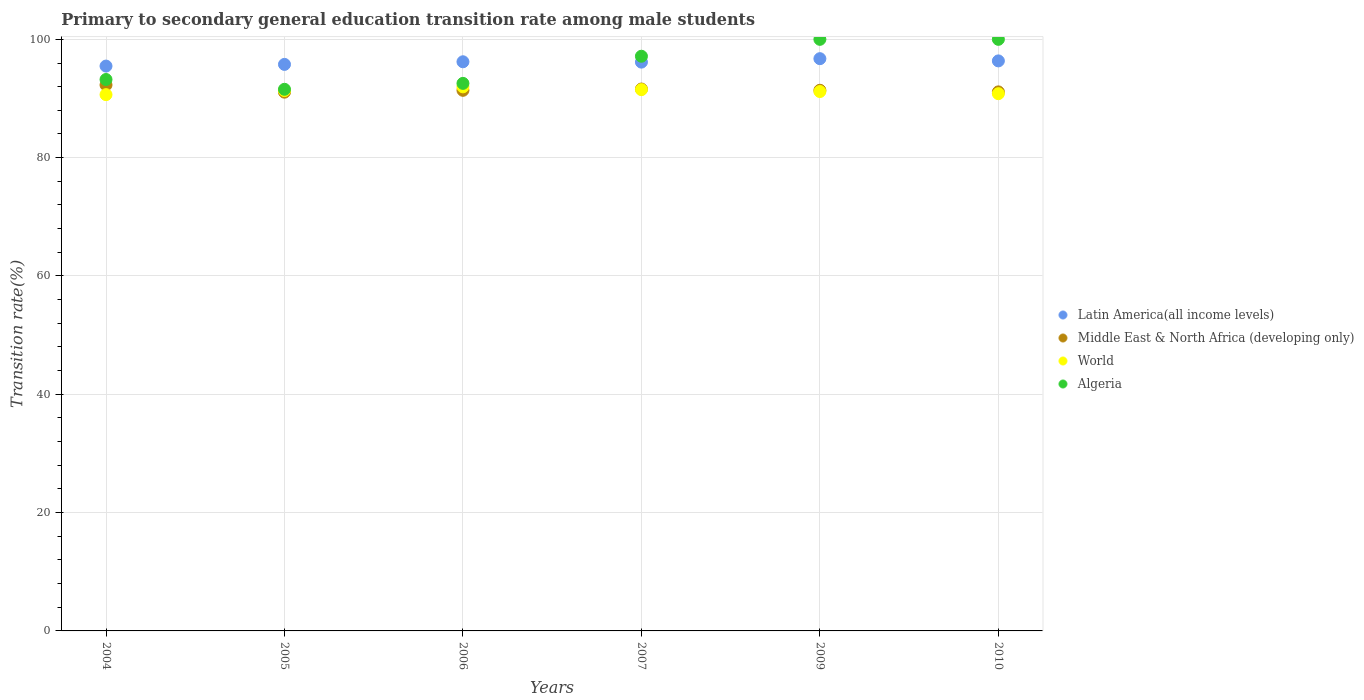How many different coloured dotlines are there?
Your answer should be compact. 4. Is the number of dotlines equal to the number of legend labels?
Your response must be concise. Yes. What is the transition rate in World in 2007?
Keep it short and to the point. 91.5. Across all years, what is the maximum transition rate in Middle East & North Africa (developing only)?
Offer a terse response. 92.29. Across all years, what is the minimum transition rate in World?
Your answer should be compact. 90.65. In which year was the transition rate in Algeria maximum?
Offer a terse response. 2009. In which year was the transition rate in Middle East & North Africa (developing only) minimum?
Make the answer very short. 2005. What is the total transition rate in Middle East & North Africa (developing only) in the graph?
Keep it short and to the point. 548.86. What is the difference between the transition rate in Latin America(all income levels) in 2005 and that in 2007?
Ensure brevity in your answer.  -0.38. What is the difference between the transition rate in Latin America(all income levels) in 2004 and the transition rate in World in 2007?
Make the answer very short. 3.98. What is the average transition rate in Latin America(all income levels) per year?
Your answer should be compact. 96.11. In the year 2009, what is the difference between the transition rate in Middle East & North Africa (developing only) and transition rate in World?
Offer a very short reply. 0.22. What is the ratio of the transition rate in Middle East & North Africa (developing only) in 2007 to that in 2010?
Your answer should be compact. 1.01. Is the transition rate in World in 2005 less than that in 2007?
Offer a terse response. Yes. What is the difference between the highest and the second highest transition rate in World?
Your answer should be very brief. 0.47. What is the difference between the highest and the lowest transition rate in World?
Your answer should be very brief. 1.32. In how many years, is the transition rate in Middle East & North Africa (developing only) greater than the average transition rate in Middle East & North Africa (developing only) taken over all years?
Ensure brevity in your answer.  2. Is the sum of the transition rate in World in 2009 and 2010 greater than the maximum transition rate in Middle East & North Africa (developing only) across all years?
Provide a succinct answer. Yes. Does the transition rate in Middle East & North Africa (developing only) monotonically increase over the years?
Provide a succinct answer. No. Is the transition rate in Latin America(all income levels) strictly greater than the transition rate in Middle East & North Africa (developing only) over the years?
Offer a terse response. Yes. How many dotlines are there?
Your answer should be very brief. 4. How many years are there in the graph?
Provide a short and direct response. 6. What is the difference between two consecutive major ticks on the Y-axis?
Your response must be concise. 20. Are the values on the major ticks of Y-axis written in scientific E-notation?
Keep it short and to the point. No. Where does the legend appear in the graph?
Provide a short and direct response. Center right. How many legend labels are there?
Ensure brevity in your answer.  4. How are the legend labels stacked?
Your answer should be compact. Vertical. What is the title of the graph?
Your response must be concise. Primary to secondary general education transition rate among male students. What is the label or title of the X-axis?
Offer a terse response. Years. What is the label or title of the Y-axis?
Make the answer very short. Transition rate(%). What is the Transition rate(%) of Latin America(all income levels) in 2004?
Your answer should be compact. 95.48. What is the Transition rate(%) of Middle East & North Africa (developing only) in 2004?
Your answer should be compact. 92.29. What is the Transition rate(%) in World in 2004?
Your answer should be very brief. 90.65. What is the Transition rate(%) in Algeria in 2004?
Provide a short and direct response. 93.21. What is the Transition rate(%) of Latin America(all income levels) in 2005?
Your answer should be very brief. 95.76. What is the Transition rate(%) in Middle East & North Africa (developing only) in 2005?
Keep it short and to the point. 91.07. What is the Transition rate(%) in World in 2005?
Provide a short and direct response. 91.34. What is the Transition rate(%) of Algeria in 2005?
Provide a short and direct response. 91.56. What is the Transition rate(%) in Latin America(all income levels) in 2006?
Provide a succinct answer. 96.21. What is the Transition rate(%) in Middle East & North Africa (developing only) in 2006?
Make the answer very short. 91.38. What is the Transition rate(%) in World in 2006?
Offer a very short reply. 91.97. What is the Transition rate(%) in Algeria in 2006?
Offer a terse response. 92.56. What is the Transition rate(%) of Latin America(all income levels) in 2007?
Offer a terse response. 96.15. What is the Transition rate(%) in Middle East & North Africa (developing only) in 2007?
Offer a very short reply. 91.6. What is the Transition rate(%) of World in 2007?
Provide a short and direct response. 91.5. What is the Transition rate(%) in Algeria in 2007?
Give a very brief answer. 97.14. What is the Transition rate(%) in Latin America(all income levels) in 2009?
Keep it short and to the point. 96.73. What is the Transition rate(%) of Middle East & North Africa (developing only) in 2009?
Provide a short and direct response. 91.39. What is the Transition rate(%) of World in 2009?
Offer a very short reply. 91.18. What is the Transition rate(%) in Latin America(all income levels) in 2010?
Provide a succinct answer. 96.36. What is the Transition rate(%) of Middle East & North Africa (developing only) in 2010?
Provide a short and direct response. 91.12. What is the Transition rate(%) in World in 2010?
Offer a very short reply. 90.81. What is the Transition rate(%) of Algeria in 2010?
Offer a very short reply. 100. Across all years, what is the maximum Transition rate(%) in Latin America(all income levels)?
Provide a succinct answer. 96.73. Across all years, what is the maximum Transition rate(%) of Middle East & North Africa (developing only)?
Provide a short and direct response. 92.29. Across all years, what is the maximum Transition rate(%) in World?
Your answer should be very brief. 91.97. Across all years, what is the minimum Transition rate(%) in Latin America(all income levels)?
Offer a very short reply. 95.48. Across all years, what is the minimum Transition rate(%) in Middle East & North Africa (developing only)?
Offer a terse response. 91.07. Across all years, what is the minimum Transition rate(%) of World?
Your answer should be compact. 90.65. Across all years, what is the minimum Transition rate(%) in Algeria?
Make the answer very short. 91.56. What is the total Transition rate(%) in Latin America(all income levels) in the graph?
Ensure brevity in your answer.  576.69. What is the total Transition rate(%) of Middle East & North Africa (developing only) in the graph?
Your answer should be very brief. 548.86. What is the total Transition rate(%) in World in the graph?
Offer a very short reply. 547.45. What is the total Transition rate(%) of Algeria in the graph?
Give a very brief answer. 574.47. What is the difference between the Transition rate(%) of Latin America(all income levels) in 2004 and that in 2005?
Provide a short and direct response. -0.28. What is the difference between the Transition rate(%) in Middle East & North Africa (developing only) in 2004 and that in 2005?
Provide a succinct answer. 1.22. What is the difference between the Transition rate(%) in World in 2004 and that in 2005?
Offer a very short reply. -0.69. What is the difference between the Transition rate(%) in Algeria in 2004 and that in 2005?
Ensure brevity in your answer.  1.66. What is the difference between the Transition rate(%) of Latin America(all income levels) in 2004 and that in 2006?
Give a very brief answer. -0.73. What is the difference between the Transition rate(%) in Middle East & North Africa (developing only) in 2004 and that in 2006?
Give a very brief answer. 0.91. What is the difference between the Transition rate(%) of World in 2004 and that in 2006?
Your response must be concise. -1.31. What is the difference between the Transition rate(%) of Algeria in 2004 and that in 2006?
Your answer should be compact. 0.65. What is the difference between the Transition rate(%) in Latin America(all income levels) in 2004 and that in 2007?
Keep it short and to the point. -0.67. What is the difference between the Transition rate(%) in Middle East & North Africa (developing only) in 2004 and that in 2007?
Your answer should be compact. 0.68. What is the difference between the Transition rate(%) in World in 2004 and that in 2007?
Keep it short and to the point. -0.85. What is the difference between the Transition rate(%) in Algeria in 2004 and that in 2007?
Ensure brevity in your answer.  -3.93. What is the difference between the Transition rate(%) in Latin America(all income levels) in 2004 and that in 2009?
Make the answer very short. -1.25. What is the difference between the Transition rate(%) of Middle East & North Africa (developing only) in 2004 and that in 2009?
Make the answer very short. 0.89. What is the difference between the Transition rate(%) in World in 2004 and that in 2009?
Ensure brevity in your answer.  -0.53. What is the difference between the Transition rate(%) in Algeria in 2004 and that in 2009?
Keep it short and to the point. -6.79. What is the difference between the Transition rate(%) in Latin America(all income levels) in 2004 and that in 2010?
Your response must be concise. -0.87. What is the difference between the Transition rate(%) of Middle East & North Africa (developing only) in 2004 and that in 2010?
Keep it short and to the point. 1.17. What is the difference between the Transition rate(%) in World in 2004 and that in 2010?
Your answer should be very brief. -0.16. What is the difference between the Transition rate(%) of Algeria in 2004 and that in 2010?
Provide a short and direct response. -6.79. What is the difference between the Transition rate(%) of Latin America(all income levels) in 2005 and that in 2006?
Offer a terse response. -0.44. What is the difference between the Transition rate(%) of Middle East & North Africa (developing only) in 2005 and that in 2006?
Make the answer very short. -0.31. What is the difference between the Transition rate(%) of World in 2005 and that in 2006?
Offer a very short reply. -0.63. What is the difference between the Transition rate(%) of Algeria in 2005 and that in 2006?
Ensure brevity in your answer.  -1. What is the difference between the Transition rate(%) of Latin America(all income levels) in 2005 and that in 2007?
Keep it short and to the point. -0.38. What is the difference between the Transition rate(%) in Middle East & North Africa (developing only) in 2005 and that in 2007?
Provide a short and direct response. -0.53. What is the difference between the Transition rate(%) in World in 2005 and that in 2007?
Your answer should be compact. -0.16. What is the difference between the Transition rate(%) in Algeria in 2005 and that in 2007?
Your answer should be compact. -5.59. What is the difference between the Transition rate(%) in Latin America(all income levels) in 2005 and that in 2009?
Give a very brief answer. -0.97. What is the difference between the Transition rate(%) of Middle East & North Africa (developing only) in 2005 and that in 2009?
Your answer should be compact. -0.32. What is the difference between the Transition rate(%) of World in 2005 and that in 2009?
Your answer should be very brief. 0.16. What is the difference between the Transition rate(%) of Algeria in 2005 and that in 2009?
Your response must be concise. -8.44. What is the difference between the Transition rate(%) of Latin America(all income levels) in 2005 and that in 2010?
Keep it short and to the point. -0.59. What is the difference between the Transition rate(%) in Middle East & North Africa (developing only) in 2005 and that in 2010?
Your response must be concise. -0.05. What is the difference between the Transition rate(%) in World in 2005 and that in 2010?
Offer a terse response. 0.53. What is the difference between the Transition rate(%) of Algeria in 2005 and that in 2010?
Give a very brief answer. -8.44. What is the difference between the Transition rate(%) of Latin America(all income levels) in 2006 and that in 2007?
Provide a short and direct response. 0.06. What is the difference between the Transition rate(%) of Middle East & North Africa (developing only) in 2006 and that in 2007?
Offer a very short reply. -0.22. What is the difference between the Transition rate(%) of World in 2006 and that in 2007?
Offer a terse response. 0.47. What is the difference between the Transition rate(%) in Algeria in 2006 and that in 2007?
Keep it short and to the point. -4.59. What is the difference between the Transition rate(%) of Latin America(all income levels) in 2006 and that in 2009?
Your answer should be compact. -0.52. What is the difference between the Transition rate(%) of Middle East & North Africa (developing only) in 2006 and that in 2009?
Provide a succinct answer. -0.01. What is the difference between the Transition rate(%) in World in 2006 and that in 2009?
Provide a short and direct response. 0.79. What is the difference between the Transition rate(%) in Algeria in 2006 and that in 2009?
Your answer should be very brief. -7.44. What is the difference between the Transition rate(%) in Latin America(all income levels) in 2006 and that in 2010?
Make the answer very short. -0.15. What is the difference between the Transition rate(%) of Middle East & North Africa (developing only) in 2006 and that in 2010?
Offer a terse response. 0.26. What is the difference between the Transition rate(%) of World in 2006 and that in 2010?
Your answer should be compact. 1.15. What is the difference between the Transition rate(%) in Algeria in 2006 and that in 2010?
Provide a succinct answer. -7.44. What is the difference between the Transition rate(%) of Latin America(all income levels) in 2007 and that in 2009?
Offer a very short reply. -0.58. What is the difference between the Transition rate(%) in Middle East & North Africa (developing only) in 2007 and that in 2009?
Provide a short and direct response. 0.21. What is the difference between the Transition rate(%) in World in 2007 and that in 2009?
Keep it short and to the point. 0.32. What is the difference between the Transition rate(%) in Algeria in 2007 and that in 2009?
Keep it short and to the point. -2.86. What is the difference between the Transition rate(%) of Latin America(all income levels) in 2007 and that in 2010?
Ensure brevity in your answer.  -0.21. What is the difference between the Transition rate(%) of Middle East & North Africa (developing only) in 2007 and that in 2010?
Your response must be concise. 0.48. What is the difference between the Transition rate(%) in World in 2007 and that in 2010?
Your answer should be very brief. 0.68. What is the difference between the Transition rate(%) in Algeria in 2007 and that in 2010?
Give a very brief answer. -2.86. What is the difference between the Transition rate(%) in Latin America(all income levels) in 2009 and that in 2010?
Offer a very short reply. 0.38. What is the difference between the Transition rate(%) of Middle East & North Africa (developing only) in 2009 and that in 2010?
Give a very brief answer. 0.27. What is the difference between the Transition rate(%) of World in 2009 and that in 2010?
Your answer should be very brief. 0.36. What is the difference between the Transition rate(%) in Algeria in 2009 and that in 2010?
Provide a succinct answer. 0. What is the difference between the Transition rate(%) in Latin America(all income levels) in 2004 and the Transition rate(%) in Middle East & North Africa (developing only) in 2005?
Your response must be concise. 4.41. What is the difference between the Transition rate(%) in Latin America(all income levels) in 2004 and the Transition rate(%) in World in 2005?
Keep it short and to the point. 4.14. What is the difference between the Transition rate(%) in Latin America(all income levels) in 2004 and the Transition rate(%) in Algeria in 2005?
Your answer should be very brief. 3.93. What is the difference between the Transition rate(%) of Middle East & North Africa (developing only) in 2004 and the Transition rate(%) of World in 2005?
Your answer should be very brief. 0.95. What is the difference between the Transition rate(%) in Middle East & North Africa (developing only) in 2004 and the Transition rate(%) in Algeria in 2005?
Give a very brief answer. 0.73. What is the difference between the Transition rate(%) of World in 2004 and the Transition rate(%) of Algeria in 2005?
Provide a succinct answer. -0.9. What is the difference between the Transition rate(%) in Latin America(all income levels) in 2004 and the Transition rate(%) in Middle East & North Africa (developing only) in 2006?
Your answer should be very brief. 4.1. What is the difference between the Transition rate(%) in Latin America(all income levels) in 2004 and the Transition rate(%) in World in 2006?
Give a very brief answer. 3.51. What is the difference between the Transition rate(%) in Latin America(all income levels) in 2004 and the Transition rate(%) in Algeria in 2006?
Your answer should be very brief. 2.92. What is the difference between the Transition rate(%) of Middle East & North Africa (developing only) in 2004 and the Transition rate(%) of World in 2006?
Provide a succinct answer. 0.32. What is the difference between the Transition rate(%) in Middle East & North Africa (developing only) in 2004 and the Transition rate(%) in Algeria in 2006?
Provide a succinct answer. -0.27. What is the difference between the Transition rate(%) in World in 2004 and the Transition rate(%) in Algeria in 2006?
Keep it short and to the point. -1.91. What is the difference between the Transition rate(%) in Latin America(all income levels) in 2004 and the Transition rate(%) in Middle East & North Africa (developing only) in 2007?
Make the answer very short. 3.88. What is the difference between the Transition rate(%) in Latin America(all income levels) in 2004 and the Transition rate(%) in World in 2007?
Offer a very short reply. 3.98. What is the difference between the Transition rate(%) in Latin America(all income levels) in 2004 and the Transition rate(%) in Algeria in 2007?
Keep it short and to the point. -1.66. What is the difference between the Transition rate(%) in Middle East & North Africa (developing only) in 2004 and the Transition rate(%) in World in 2007?
Provide a succinct answer. 0.79. What is the difference between the Transition rate(%) in Middle East & North Africa (developing only) in 2004 and the Transition rate(%) in Algeria in 2007?
Your response must be concise. -4.85. What is the difference between the Transition rate(%) in World in 2004 and the Transition rate(%) in Algeria in 2007?
Your answer should be very brief. -6.49. What is the difference between the Transition rate(%) of Latin America(all income levels) in 2004 and the Transition rate(%) of Middle East & North Africa (developing only) in 2009?
Offer a very short reply. 4.09. What is the difference between the Transition rate(%) of Latin America(all income levels) in 2004 and the Transition rate(%) of World in 2009?
Keep it short and to the point. 4.3. What is the difference between the Transition rate(%) of Latin America(all income levels) in 2004 and the Transition rate(%) of Algeria in 2009?
Give a very brief answer. -4.52. What is the difference between the Transition rate(%) in Middle East & North Africa (developing only) in 2004 and the Transition rate(%) in World in 2009?
Give a very brief answer. 1.11. What is the difference between the Transition rate(%) in Middle East & North Africa (developing only) in 2004 and the Transition rate(%) in Algeria in 2009?
Keep it short and to the point. -7.71. What is the difference between the Transition rate(%) in World in 2004 and the Transition rate(%) in Algeria in 2009?
Provide a succinct answer. -9.35. What is the difference between the Transition rate(%) in Latin America(all income levels) in 2004 and the Transition rate(%) in Middle East & North Africa (developing only) in 2010?
Provide a short and direct response. 4.36. What is the difference between the Transition rate(%) of Latin America(all income levels) in 2004 and the Transition rate(%) of World in 2010?
Provide a succinct answer. 4.67. What is the difference between the Transition rate(%) of Latin America(all income levels) in 2004 and the Transition rate(%) of Algeria in 2010?
Your answer should be very brief. -4.52. What is the difference between the Transition rate(%) of Middle East & North Africa (developing only) in 2004 and the Transition rate(%) of World in 2010?
Offer a very short reply. 1.47. What is the difference between the Transition rate(%) in Middle East & North Africa (developing only) in 2004 and the Transition rate(%) in Algeria in 2010?
Ensure brevity in your answer.  -7.71. What is the difference between the Transition rate(%) of World in 2004 and the Transition rate(%) of Algeria in 2010?
Give a very brief answer. -9.35. What is the difference between the Transition rate(%) of Latin America(all income levels) in 2005 and the Transition rate(%) of Middle East & North Africa (developing only) in 2006?
Make the answer very short. 4.38. What is the difference between the Transition rate(%) of Latin America(all income levels) in 2005 and the Transition rate(%) of World in 2006?
Ensure brevity in your answer.  3.8. What is the difference between the Transition rate(%) in Latin America(all income levels) in 2005 and the Transition rate(%) in Algeria in 2006?
Ensure brevity in your answer.  3.21. What is the difference between the Transition rate(%) of Middle East & North Africa (developing only) in 2005 and the Transition rate(%) of World in 2006?
Provide a succinct answer. -0.9. What is the difference between the Transition rate(%) of Middle East & North Africa (developing only) in 2005 and the Transition rate(%) of Algeria in 2006?
Offer a terse response. -1.49. What is the difference between the Transition rate(%) in World in 2005 and the Transition rate(%) in Algeria in 2006?
Give a very brief answer. -1.22. What is the difference between the Transition rate(%) in Latin America(all income levels) in 2005 and the Transition rate(%) in Middle East & North Africa (developing only) in 2007?
Provide a short and direct response. 4.16. What is the difference between the Transition rate(%) in Latin America(all income levels) in 2005 and the Transition rate(%) in World in 2007?
Provide a short and direct response. 4.27. What is the difference between the Transition rate(%) of Latin America(all income levels) in 2005 and the Transition rate(%) of Algeria in 2007?
Offer a very short reply. -1.38. What is the difference between the Transition rate(%) in Middle East & North Africa (developing only) in 2005 and the Transition rate(%) in World in 2007?
Make the answer very short. -0.43. What is the difference between the Transition rate(%) in Middle East & North Africa (developing only) in 2005 and the Transition rate(%) in Algeria in 2007?
Keep it short and to the point. -6.07. What is the difference between the Transition rate(%) in World in 2005 and the Transition rate(%) in Algeria in 2007?
Offer a terse response. -5.8. What is the difference between the Transition rate(%) of Latin America(all income levels) in 2005 and the Transition rate(%) of Middle East & North Africa (developing only) in 2009?
Your answer should be very brief. 4.37. What is the difference between the Transition rate(%) of Latin America(all income levels) in 2005 and the Transition rate(%) of World in 2009?
Offer a very short reply. 4.59. What is the difference between the Transition rate(%) in Latin America(all income levels) in 2005 and the Transition rate(%) in Algeria in 2009?
Provide a succinct answer. -4.24. What is the difference between the Transition rate(%) of Middle East & North Africa (developing only) in 2005 and the Transition rate(%) of World in 2009?
Your response must be concise. -0.11. What is the difference between the Transition rate(%) of Middle East & North Africa (developing only) in 2005 and the Transition rate(%) of Algeria in 2009?
Ensure brevity in your answer.  -8.93. What is the difference between the Transition rate(%) of World in 2005 and the Transition rate(%) of Algeria in 2009?
Ensure brevity in your answer.  -8.66. What is the difference between the Transition rate(%) of Latin America(all income levels) in 2005 and the Transition rate(%) of Middle East & North Africa (developing only) in 2010?
Offer a terse response. 4.65. What is the difference between the Transition rate(%) of Latin America(all income levels) in 2005 and the Transition rate(%) of World in 2010?
Offer a very short reply. 4.95. What is the difference between the Transition rate(%) of Latin America(all income levels) in 2005 and the Transition rate(%) of Algeria in 2010?
Keep it short and to the point. -4.24. What is the difference between the Transition rate(%) of Middle East & North Africa (developing only) in 2005 and the Transition rate(%) of World in 2010?
Ensure brevity in your answer.  0.26. What is the difference between the Transition rate(%) in Middle East & North Africa (developing only) in 2005 and the Transition rate(%) in Algeria in 2010?
Your answer should be compact. -8.93. What is the difference between the Transition rate(%) in World in 2005 and the Transition rate(%) in Algeria in 2010?
Give a very brief answer. -8.66. What is the difference between the Transition rate(%) of Latin America(all income levels) in 2006 and the Transition rate(%) of Middle East & North Africa (developing only) in 2007?
Offer a very short reply. 4.6. What is the difference between the Transition rate(%) in Latin America(all income levels) in 2006 and the Transition rate(%) in World in 2007?
Keep it short and to the point. 4.71. What is the difference between the Transition rate(%) of Latin America(all income levels) in 2006 and the Transition rate(%) of Algeria in 2007?
Provide a short and direct response. -0.94. What is the difference between the Transition rate(%) of Middle East & North Africa (developing only) in 2006 and the Transition rate(%) of World in 2007?
Offer a very short reply. -0.12. What is the difference between the Transition rate(%) in Middle East & North Africa (developing only) in 2006 and the Transition rate(%) in Algeria in 2007?
Make the answer very short. -5.76. What is the difference between the Transition rate(%) in World in 2006 and the Transition rate(%) in Algeria in 2007?
Your response must be concise. -5.18. What is the difference between the Transition rate(%) of Latin America(all income levels) in 2006 and the Transition rate(%) of Middle East & North Africa (developing only) in 2009?
Your response must be concise. 4.81. What is the difference between the Transition rate(%) in Latin America(all income levels) in 2006 and the Transition rate(%) in World in 2009?
Your answer should be very brief. 5.03. What is the difference between the Transition rate(%) in Latin America(all income levels) in 2006 and the Transition rate(%) in Algeria in 2009?
Your answer should be very brief. -3.79. What is the difference between the Transition rate(%) of Middle East & North Africa (developing only) in 2006 and the Transition rate(%) of World in 2009?
Your response must be concise. 0.21. What is the difference between the Transition rate(%) of Middle East & North Africa (developing only) in 2006 and the Transition rate(%) of Algeria in 2009?
Your answer should be very brief. -8.62. What is the difference between the Transition rate(%) of World in 2006 and the Transition rate(%) of Algeria in 2009?
Provide a short and direct response. -8.03. What is the difference between the Transition rate(%) in Latin America(all income levels) in 2006 and the Transition rate(%) in Middle East & North Africa (developing only) in 2010?
Ensure brevity in your answer.  5.09. What is the difference between the Transition rate(%) in Latin America(all income levels) in 2006 and the Transition rate(%) in World in 2010?
Offer a very short reply. 5.39. What is the difference between the Transition rate(%) of Latin America(all income levels) in 2006 and the Transition rate(%) of Algeria in 2010?
Your response must be concise. -3.79. What is the difference between the Transition rate(%) in Middle East & North Africa (developing only) in 2006 and the Transition rate(%) in World in 2010?
Make the answer very short. 0.57. What is the difference between the Transition rate(%) of Middle East & North Africa (developing only) in 2006 and the Transition rate(%) of Algeria in 2010?
Offer a very short reply. -8.62. What is the difference between the Transition rate(%) of World in 2006 and the Transition rate(%) of Algeria in 2010?
Your answer should be very brief. -8.03. What is the difference between the Transition rate(%) in Latin America(all income levels) in 2007 and the Transition rate(%) in Middle East & North Africa (developing only) in 2009?
Offer a terse response. 4.75. What is the difference between the Transition rate(%) in Latin America(all income levels) in 2007 and the Transition rate(%) in World in 2009?
Provide a succinct answer. 4.97. What is the difference between the Transition rate(%) of Latin America(all income levels) in 2007 and the Transition rate(%) of Algeria in 2009?
Your answer should be very brief. -3.85. What is the difference between the Transition rate(%) of Middle East & North Africa (developing only) in 2007 and the Transition rate(%) of World in 2009?
Give a very brief answer. 0.43. What is the difference between the Transition rate(%) in Middle East & North Africa (developing only) in 2007 and the Transition rate(%) in Algeria in 2009?
Keep it short and to the point. -8.4. What is the difference between the Transition rate(%) in World in 2007 and the Transition rate(%) in Algeria in 2009?
Your answer should be very brief. -8.5. What is the difference between the Transition rate(%) of Latin America(all income levels) in 2007 and the Transition rate(%) of Middle East & North Africa (developing only) in 2010?
Your answer should be very brief. 5.03. What is the difference between the Transition rate(%) in Latin America(all income levels) in 2007 and the Transition rate(%) in World in 2010?
Your answer should be very brief. 5.33. What is the difference between the Transition rate(%) in Latin America(all income levels) in 2007 and the Transition rate(%) in Algeria in 2010?
Give a very brief answer. -3.85. What is the difference between the Transition rate(%) in Middle East & North Africa (developing only) in 2007 and the Transition rate(%) in World in 2010?
Offer a terse response. 0.79. What is the difference between the Transition rate(%) in Middle East & North Africa (developing only) in 2007 and the Transition rate(%) in Algeria in 2010?
Provide a short and direct response. -8.4. What is the difference between the Transition rate(%) in World in 2007 and the Transition rate(%) in Algeria in 2010?
Provide a succinct answer. -8.5. What is the difference between the Transition rate(%) in Latin America(all income levels) in 2009 and the Transition rate(%) in Middle East & North Africa (developing only) in 2010?
Provide a short and direct response. 5.61. What is the difference between the Transition rate(%) of Latin America(all income levels) in 2009 and the Transition rate(%) of World in 2010?
Your response must be concise. 5.92. What is the difference between the Transition rate(%) of Latin America(all income levels) in 2009 and the Transition rate(%) of Algeria in 2010?
Keep it short and to the point. -3.27. What is the difference between the Transition rate(%) of Middle East & North Africa (developing only) in 2009 and the Transition rate(%) of World in 2010?
Offer a terse response. 0.58. What is the difference between the Transition rate(%) of Middle East & North Africa (developing only) in 2009 and the Transition rate(%) of Algeria in 2010?
Your answer should be compact. -8.61. What is the difference between the Transition rate(%) in World in 2009 and the Transition rate(%) in Algeria in 2010?
Offer a terse response. -8.82. What is the average Transition rate(%) of Latin America(all income levels) per year?
Offer a very short reply. 96.11. What is the average Transition rate(%) in Middle East & North Africa (developing only) per year?
Provide a short and direct response. 91.48. What is the average Transition rate(%) of World per year?
Offer a terse response. 91.24. What is the average Transition rate(%) in Algeria per year?
Provide a short and direct response. 95.74. In the year 2004, what is the difference between the Transition rate(%) of Latin America(all income levels) and Transition rate(%) of Middle East & North Africa (developing only)?
Offer a very short reply. 3.19. In the year 2004, what is the difference between the Transition rate(%) in Latin America(all income levels) and Transition rate(%) in World?
Make the answer very short. 4.83. In the year 2004, what is the difference between the Transition rate(%) of Latin America(all income levels) and Transition rate(%) of Algeria?
Ensure brevity in your answer.  2.27. In the year 2004, what is the difference between the Transition rate(%) in Middle East & North Africa (developing only) and Transition rate(%) in World?
Your answer should be very brief. 1.64. In the year 2004, what is the difference between the Transition rate(%) in Middle East & North Africa (developing only) and Transition rate(%) in Algeria?
Give a very brief answer. -0.92. In the year 2004, what is the difference between the Transition rate(%) of World and Transition rate(%) of Algeria?
Ensure brevity in your answer.  -2.56. In the year 2005, what is the difference between the Transition rate(%) in Latin America(all income levels) and Transition rate(%) in Middle East & North Africa (developing only)?
Offer a terse response. 4.69. In the year 2005, what is the difference between the Transition rate(%) in Latin America(all income levels) and Transition rate(%) in World?
Give a very brief answer. 4.42. In the year 2005, what is the difference between the Transition rate(%) in Latin America(all income levels) and Transition rate(%) in Algeria?
Your response must be concise. 4.21. In the year 2005, what is the difference between the Transition rate(%) in Middle East & North Africa (developing only) and Transition rate(%) in World?
Your answer should be compact. -0.27. In the year 2005, what is the difference between the Transition rate(%) in Middle East & North Africa (developing only) and Transition rate(%) in Algeria?
Keep it short and to the point. -0.48. In the year 2005, what is the difference between the Transition rate(%) of World and Transition rate(%) of Algeria?
Your answer should be compact. -0.21. In the year 2006, what is the difference between the Transition rate(%) in Latin America(all income levels) and Transition rate(%) in Middle East & North Africa (developing only)?
Offer a very short reply. 4.83. In the year 2006, what is the difference between the Transition rate(%) in Latin America(all income levels) and Transition rate(%) in World?
Make the answer very short. 4.24. In the year 2006, what is the difference between the Transition rate(%) of Latin America(all income levels) and Transition rate(%) of Algeria?
Your response must be concise. 3.65. In the year 2006, what is the difference between the Transition rate(%) in Middle East & North Africa (developing only) and Transition rate(%) in World?
Provide a succinct answer. -0.58. In the year 2006, what is the difference between the Transition rate(%) of Middle East & North Africa (developing only) and Transition rate(%) of Algeria?
Offer a terse response. -1.17. In the year 2006, what is the difference between the Transition rate(%) of World and Transition rate(%) of Algeria?
Keep it short and to the point. -0.59. In the year 2007, what is the difference between the Transition rate(%) in Latin America(all income levels) and Transition rate(%) in Middle East & North Africa (developing only)?
Offer a terse response. 4.54. In the year 2007, what is the difference between the Transition rate(%) in Latin America(all income levels) and Transition rate(%) in World?
Offer a very short reply. 4.65. In the year 2007, what is the difference between the Transition rate(%) of Latin America(all income levels) and Transition rate(%) of Algeria?
Give a very brief answer. -0.99. In the year 2007, what is the difference between the Transition rate(%) in Middle East & North Africa (developing only) and Transition rate(%) in World?
Make the answer very short. 0.11. In the year 2007, what is the difference between the Transition rate(%) of Middle East & North Africa (developing only) and Transition rate(%) of Algeria?
Provide a succinct answer. -5.54. In the year 2007, what is the difference between the Transition rate(%) in World and Transition rate(%) in Algeria?
Offer a very short reply. -5.65. In the year 2009, what is the difference between the Transition rate(%) of Latin America(all income levels) and Transition rate(%) of Middle East & North Africa (developing only)?
Give a very brief answer. 5.34. In the year 2009, what is the difference between the Transition rate(%) of Latin America(all income levels) and Transition rate(%) of World?
Your response must be concise. 5.56. In the year 2009, what is the difference between the Transition rate(%) of Latin America(all income levels) and Transition rate(%) of Algeria?
Keep it short and to the point. -3.27. In the year 2009, what is the difference between the Transition rate(%) in Middle East & North Africa (developing only) and Transition rate(%) in World?
Ensure brevity in your answer.  0.22. In the year 2009, what is the difference between the Transition rate(%) of Middle East & North Africa (developing only) and Transition rate(%) of Algeria?
Your answer should be compact. -8.61. In the year 2009, what is the difference between the Transition rate(%) in World and Transition rate(%) in Algeria?
Offer a very short reply. -8.82. In the year 2010, what is the difference between the Transition rate(%) in Latin America(all income levels) and Transition rate(%) in Middle East & North Africa (developing only)?
Keep it short and to the point. 5.24. In the year 2010, what is the difference between the Transition rate(%) of Latin America(all income levels) and Transition rate(%) of World?
Your response must be concise. 5.54. In the year 2010, what is the difference between the Transition rate(%) of Latin America(all income levels) and Transition rate(%) of Algeria?
Give a very brief answer. -3.64. In the year 2010, what is the difference between the Transition rate(%) in Middle East & North Africa (developing only) and Transition rate(%) in World?
Your response must be concise. 0.31. In the year 2010, what is the difference between the Transition rate(%) in Middle East & North Africa (developing only) and Transition rate(%) in Algeria?
Provide a succinct answer. -8.88. In the year 2010, what is the difference between the Transition rate(%) of World and Transition rate(%) of Algeria?
Provide a short and direct response. -9.19. What is the ratio of the Transition rate(%) of Latin America(all income levels) in 2004 to that in 2005?
Your response must be concise. 1. What is the ratio of the Transition rate(%) in Middle East & North Africa (developing only) in 2004 to that in 2005?
Provide a short and direct response. 1.01. What is the ratio of the Transition rate(%) of Algeria in 2004 to that in 2005?
Your answer should be very brief. 1.02. What is the ratio of the Transition rate(%) of Middle East & North Africa (developing only) in 2004 to that in 2006?
Keep it short and to the point. 1.01. What is the ratio of the Transition rate(%) in World in 2004 to that in 2006?
Offer a very short reply. 0.99. What is the ratio of the Transition rate(%) in Algeria in 2004 to that in 2006?
Your answer should be compact. 1.01. What is the ratio of the Transition rate(%) of Middle East & North Africa (developing only) in 2004 to that in 2007?
Your response must be concise. 1.01. What is the ratio of the Transition rate(%) of Algeria in 2004 to that in 2007?
Your response must be concise. 0.96. What is the ratio of the Transition rate(%) in Latin America(all income levels) in 2004 to that in 2009?
Make the answer very short. 0.99. What is the ratio of the Transition rate(%) of Middle East & North Africa (developing only) in 2004 to that in 2009?
Keep it short and to the point. 1.01. What is the ratio of the Transition rate(%) of Algeria in 2004 to that in 2009?
Give a very brief answer. 0.93. What is the ratio of the Transition rate(%) in Latin America(all income levels) in 2004 to that in 2010?
Your answer should be compact. 0.99. What is the ratio of the Transition rate(%) in Middle East & North Africa (developing only) in 2004 to that in 2010?
Provide a succinct answer. 1.01. What is the ratio of the Transition rate(%) of Algeria in 2004 to that in 2010?
Your answer should be very brief. 0.93. What is the ratio of the Transition rate(%) in Latin America(all income levels) in 2005 to that in 2006?
Offer a terse response. 1. What is the ratio of the Transition rate(%) of Algeria in 2005 to that in 2006?
Provide a succinct answer. 0.99. What is the ratio of the Transition rate(%) in Middle East & North Africa (developing only) in 2005 to that in 2007?
Your response must be concise. 0.99. What is the ratio of the Transition rate(%) of World in 2005 to that in 2007?
Keep it short and to the point. 1. What is the ratio of the Transition rate(%) in Algeria in 2005 to that in 2007?
Your response must be concise. 0.94. What is the ratio of the Transition rate(%) of Latin America(all income levels) in 2005 to that in 2009?
Give a very brief answer. 0.99. What is the ratio of the Transition rate(%) of World in 2005 to that in 2009?
Offer a terse response. 1. What is the ratio of the Transition rate(%) of Algeria in 2005 to that in 2009?
Provide a short and direct response. 0.92. What is the ratio of the Transition rate(%) in Middle East & North Africa (developing only) in 2005 to that in 2010?
Offer a terse response. 1. What is the ratio of the Transition rate(%) in World in 2005 to that in 2010?
Make the answer very short. 1.01. What is the ratio of the Transition rate(%) of Algeria in 2005 to that in 2010?
Your answer should be very brief. 0.92. What is the ratio of the Transition rate(%) of Algeria in 2006 to that in 2007?
Your answer should be very brief. 0.95. What is the ratio of the Transition rate(%) in World in 2006 to that in 2009?
Provide a short and direct response. 1.01. What is the ratio of the Transition rate(%) in Algeria in 2006 to that in 2009?
Give a very brief answer. 0.93. What is the ratio of the Transition rate(%) in Latin America(all income levels) in 2006 to that in 2010?
Ensure brevity in your answer.  1. What is the ratio of the Transition rate(%) of World in 2006 to that in 2010?
Provide a succinct answer. 1.01. What is the ratio of the Transition rate(%) in Algeria in 2006 to that in 2010?
Give a very brief answer. 0.93. What is the ratio of the Transition rate(%) in Latin America(all income levels) in 2007 to that in 2009?
Ensure brevity in your answer.  0.99. What is the ratio of the Transition rate(%) in Middle East & North Africa (developing only) in 2007 to that in 2009?
Your response must be concise. 1. What is the ratio of the Transition rate(%) of World in 2007 to that in 2009?
Keep it short and to the point. 1. What is the ratio of the Transition rate(%) in Algeria in 2007 to that in 2009?
Provide a succinct answer. 0.97. What is the ratio of the Transition rate(%) in Latin America(all income levels) in 2007 to that in 2010?
Make the answer very short. 1. What is the ratio of the Transition rate(%) in World in 2007 to that in 2010?
Make the answer very short. 1.01. What is the ratio of the Transition rate(%) of Algeria in 2007 to that in 2010?
Offer a very short reply. 0.97. What is the ratio of the Transition rate(%) in Latin America(all income levels) in 2009 to that in 2010?
Make the answer very short. 1. What is the ratio of the Transition rate(%) of World in 2009 to that in 2010?
Ensure brevity in your answer.  1. What is the difference between the highest and the second highest Transition rate(%) in Latin America(all income levels)?
Ensure brevity in your answer.  0.38. What is the difference between the highest and the second highest Transition rate(%) of Middle East & North Africa (developing only)?
Provide a short and direct response. 0.68. What is the difference between the highest and the second highest Transition rate(%) in World?
Provide a succinct answer. 0.47. What is the difference between the highest and the lowest Transition rate(%) of Latin America(all income levels)?
Keep it short and to the point. 1.25. What is the difference between the highest and the lowest Transition rate(%) of Middle East & North Africa (developing only)?
Give a very brief answer. 1.22. What is the difference between the highest and the lowest Transition rate(%) of World?
Keep it short and to the point. 1.31. What is the difference between the highest and the lowest Transition rate(%) of Algeria?
Give a very brief answer. 8.44. 